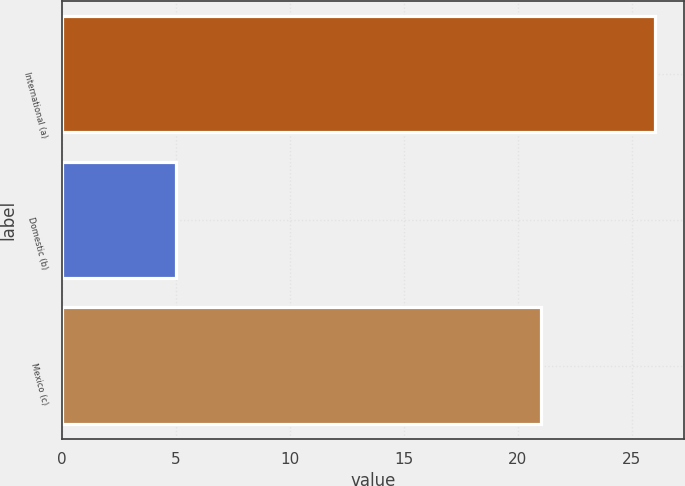<chart> <loc_0><loc_0><loc_500><loc_500><bar_chart><fcel>International (a)<fcel>Domestic (b)<fcel>Mexico (c)<nl><fcel>26<fcel>5<fcel>21<nl></chart> 